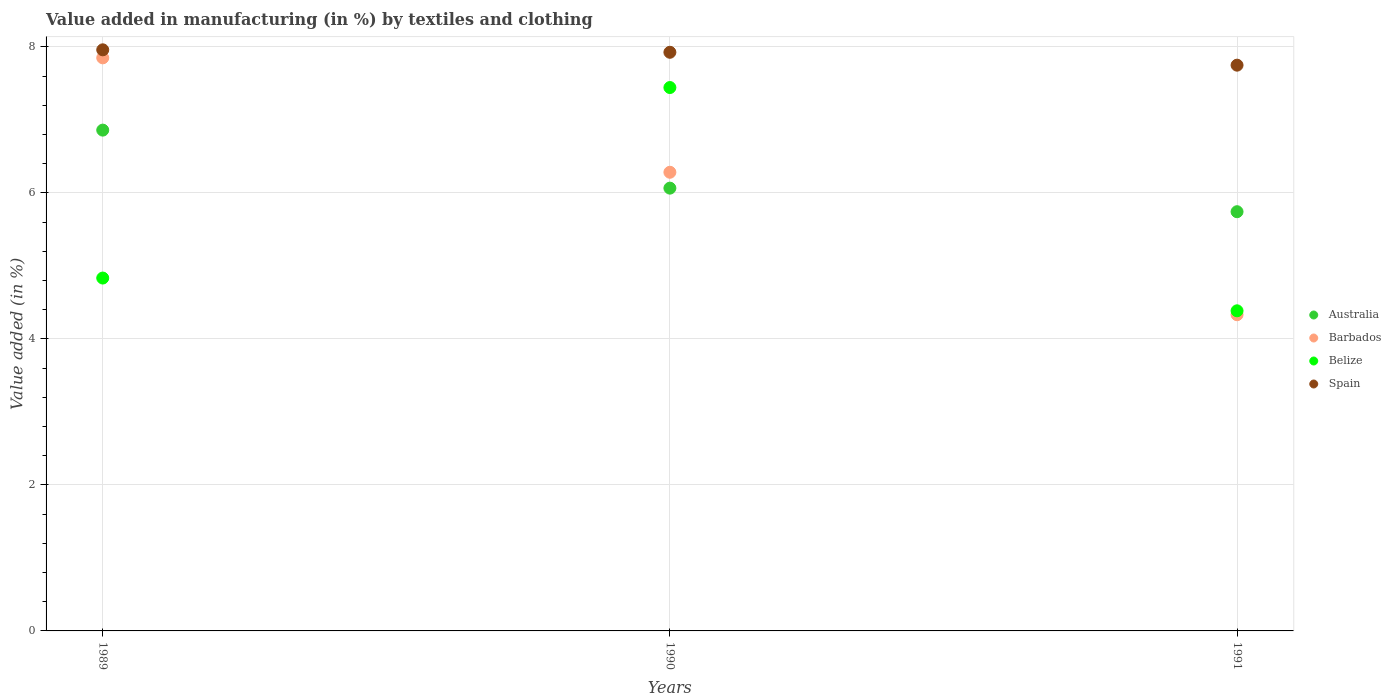Is the number of dotlines equal to the number of legend labels?
Your answer should be very brief. Yes. What is the percentage of value added in manufacturing by textiles and clothing in Belize in 1991?
Your answer should be compact. 4.39. Across all years, what is the maximum percentage of value added in manufacturing by textiles and clothing in Australia?
Offer a terse response. 6.86. Across all years, what is the minimum percentage of value added in manufacturing by textiles and clothing in Belize?
Ensure brevity in your answer.  4.39. In which year was the percentage of value added in manufacturing by textiles and clothing in Barbados maximum?
Keep it short and to the point. 1989. What is the total percentage of value added in manufacturing by textiles and clothing in Belize in the graph?
Provide a succinct answer. 16.66. What is the difference between the percentage of value added in manufacturing by textiles and clothing in Belize in 1990 and that in 1991?
Ensure brevity in your answer.  3.06. What is the difference between the percentage of value added in manufacturing by textiles and clothing in Australia in 1991 and the percentage of value added in manufacturing by textiles and clothing in Spain in 1990?
Your answer should be very brief. -2.18. What is the average percentage of value added in manufacturing by textiles and clothing in Belize per year?
Offer a terse response. 5.55. In the year 1990, what is the difference between the percentage of value added in manufacturing by textiles and clothing in Barbados and percentage of value added in manufacturing by textiles and clothing in Belize?
Give a very brief answer. -1.16. In how many years, is the percentage of value added in manufacturing by textiles and clothing in Australia greater than 3.6 %?
Make the answer very short. 3. What is the ratio of the percentage of value added in manufacturing by textiles and clothing in Barbados in 1989 to that in 1990?
Give a very brief answer. 1.25. Is the percentage of value added in manufacturing by textiles and clothing in Belize in 1989 less than that in 1991?
Keep it short and to the point. No. Is the difference between the percentage of value added in manufacturing by textiles and clothing in Barbados in 1990 and 1991 greater than the difference between the percentage of value added in manufacturing by textiles and clothing in Belize in 1990 and 1991?
Keep it short and to the point. No. What is the difference between the highest and the second highest percentage of value added in manufacturing by textiles and clothing in Australia?
Provide a succinct answer. 0.79. What is the difference between the highest and the lowest percentage of value added in manufacturing by textiles and clothing in Spain?
Provide a short and direct response. 0.21. Is the sum of the percentage of value added in manufacturing by textiles and clothing in Australia in 1990 and 1991 greater than the maximum percentage of value added in manufacturing by textiles and clothing in Barbados across all years?
Make the answer very short. Yes. Is the percentage of value added in manufacturing by textiles and clothing in Barbados strictly less than the percentage of value added in manufacturing by textiles and clothing in Spain over the years?
Provide a succinct answer. Yes. How many dotlines are there?
Give a very brief answer. 4. How many years are there in the graph?
Offer a terse response. 3. Are the values on the major ticks of Y-axis written in scientific E-notation?
Give a very brief answer. No. Where does the legend appear in the graph?
Ensure brevity in your answer.  Center right. How many legend labels are there?
Give a very brief answer. 4. How are the legend labels stacked?
Make the answer very short. Vertical. What is the title of the graph?
Offer a terse response. Value added in manufacturing (in %) by textiles and clothing. Does "Timor-Leste" appear as one of the legend labels in the graph?
Offer a terse response. No. What is the label or title of the X-axis?
Ensure brevity in your answer.  Years. What is the label or title of the Y-axis?
Keep it short and to the point. Value added (in %). What is the Value added (in %) in Australia in 1989?
Ensure brevity in your answer.  6.86. What is the Value added (in %) in Barbados in 1989?
Your response must be concise. 7.85. What is the Value added (in %) in Belize in 1989?
Provide a short and direct response. 4.83. What is the Value added (in %) in Spain in 1989?
Give a very brief answer. 7.96. What is the Value added (in %) of Australia in 1990?
Your response must be concise. 6.07. What is the Value added (in %) of Barbados in 1990?
Keep it short and to the point. 6.28. What is the Value added (in %) in Belize in 1990?
Give a very brief answer. 7.44. What is the Value added (in %) of Spain in 1990?
Provide a short and direct response. 7.93. What is the Value added (in %) in Australia in 1991?
Provide a short and direct response. 5.74. What is the Value added (in %) in Barbados in 1991?
Give a very brief answer. 4.33. What is the Value added (in %) of Belize in 1991?
Your answer should be compact. 4.39. What is the Value added (in %) in Spain in 1991?
Offer a very short reply. 7.75. Across all years, what is the maximum Value added (in %) of Australia?
Your answer should be compact. 6.86. Across all years, what is the maximum Value added (in %) of Barbados?
Your answer should be very brief. 7.85. Across all years, what is the maximum Value added (in %) of Belize?
Keep it short and to the point. 7.44. Across all years, what is the maximum Value added (in %) of Spain?
Keep it short and to the point. 7.96. Across all years, what is the minimum Value added (in %) of Australia?
Provide a short and direct response. 5.74. Across all years, what is the minimum Value added (in %) in Barbados?
Give a very brief answer. 4.33. Across all years, what is the minimum Value added (in %) of Belize?
Your answer should be compact. 4.39. Across all years, what is the minimum Value added (in %) of Spain?
Make the answer very short. 7.75. What is the total Value added (in %) of Australia in the graph?
Your answer should be very brief. 18.67. What is the total Value added (in %) in Barbados in the graph?
Make the answer very short. 18.46. What is the total Value added (in %) of Belize in the graph?
Offer a terse response. 16.66. What is the total Value added (in %) in Spain in the graph?
Give a very brief answer. 23.64. What is the difference between the Value added (in %) in Australia in 1989 and that in 1990?
Keep it short and to the point. 0.79. What is the difference between the Value added (in %) in Barbados in 1989 and that in 1990?
Give a very brief answer. 1.57. What is the difference between the Value added (in %) of Belize in 1989 and that in 1990?
Give a very brief answer. -2.61. What is the difference between the Value added (in %) of Spain in 1989 and that in 1990?
Offer a terse response. 0.03. What is the difference between the Value added (in %) of Australia in 1989 and that in 1991?
Make the answer very short. 1.12. What is the difference between the Value added (in %) of Barbados in 1989 and that in 1991?
Offer a very short reply. 3.52. What is the difference between the Value added (in %) in Belize in 1989 and that in 1991?
Provide a succinct answer. 0.45. What is the difference between the Value added (in %) of Spain in 1989 and that in 1991?
Offer a very short reply. 0.21. What is the difference between the Value added (in %) in Australia in 1990 and that in 1991?
Provide a succinct answer. 0.32. What is the difference between the Value added (in %) in Barbados in 1990 and that in 1991?
Offer a terse response. 1.95. What is the difference between the Value added (in %) of Belize in 1990 and that in 1991?
Ensure brevity in your answer.  3.06. What is the difference between the Value added (in %) of Spain in 1990 and that in 1991?
Your answer should be compact. 0.18. What is the difference between the Value added (in %) of Australia in 1989 and the Value added (in %) of Barbados in 1990?
Your response must be concise. 0.58. What is the difference between the Value added (in %) of Australia in 1989 and the Value added (in %) of Belize in 1990?
Offer a terse response. -0.58. What is the difference between the Value added (in %) in Australia in 1989 and the Value added (in %) in Spain in 1990?
Keep it short and to the point. -1.07. What is the difference between the Value added (in %) in Barbados in 1989 and the Value added (in %) in Belize in 1990?
Provide a short and direct response. 0.41. What is the difference between the Value added (in %) in Barbados in 1989 and the Value added (in %) in Spain in 1990?
Your response must be concise. -0.08. What is the difference between the Value added (in %) in Belize in 1989 and the Value added (in %) in Spain in 1990?
Provide a short and direct response. -3.09. What is the difference between the Value added (in %) in Australia in 1989 and the Value added (in %) in Barbados in 1991?
Offer a very short reply. 2.53. What is the difference between the Value added (in %) in Australia in 1989 and the Value added (in %) in Belize in 1991?
Keep it short and to the point. 2.48. What is the difference between the Value added (in %) in Australia in 1989 and the Value added (in %) in Spain in 1991?
Provide a short and direct response. -0.89. What is the difference between the Value added (in %) in Barbados in 1989 and the Value added (in %) in Belize in 1991?
Your response must be concise. 3.47. What is the difference between the Value added (in %) in Barbados in 1989 and the Value added (in %) in Spain in 1991?
Make the answer very short. 0.1. What is the difference between the Value added (in %) in Belize in 1989 and the Value added (in %) in Spain in 1991?
Offer a very short reply. -2.92. What is the difference between the Value added (in %) in Australia in 1990 and the Value added (in %) in Barbados in 1991?
Offer a very short reply. 1.73. What is the difference between the Value added (in %) in Australia in 1990 and the Value added (in %) in Belize in 1991?
Provide a succinct answer. 1.68. What is the difference between the Value added (in %) of Australia in 1990 and the Value added (in %) of Spain in 1991?
Ensure brevity in your answer.  -1.68. What is the difference between the Value added (in %) of Barbados in 1990 and the Value added (in %) of Belize in 1991?
Make the answer very short. 1.9. What is the difference between the Value added (in %) of Barbados in 1990 and the Value added (in %) of Spain in 1991?
Keep it short and to the point. -1.47. What is the difference between the Value added (in %) of Belize in 1990 and the Value added (in %) of Spain in 1991?
Provide a short and direct response. -0.31. What is the average Value added (in %) of Australia per year?
Offer a very short reply. 6.22. What is the average Value added (in %) in Barbados per year?
Keep it short and to the point. 6.15. What is the average Value added (in %) in Belize per year?
Offer a terse response. 5.55. What is the average Value added (in %) in Spain per year?
Your answer should be very brief. 7.88. In the year 1989, what is the difference between the Value added (in %) in Australia and Value added (in %) in Barbados?
Offer a terse response. -0.99. In the year 1989, what is the difference between the Value added (in %) of Australia and Value added (in %) of Belize?
Your answer should be very brief. 2.03. In the year 1989, what is the difference between the Value added (in %) in Barbados and Value added (in %) in Belize?
Provide a short and direct response. 3.02. In the year 1989, what is the difference between the Value added (in %) of Barbados and Value added (in %) of Spain?
Provide a succinct answer. -0.11. In the year 1989, what is the difference between the Value added (in %) in Belize and Value added (in %) in Spain?
Make the answer very short. -3.13. In the year 1990, what is the difference between the Value added (in %) of Australia and Value added (in %) of Barbados?
Your answer should be compact. -0.22. In the year 1990, what is the difference between the Value added (in %) of Australia and Value added (in %) of Belize?
Offer a terse response. -1.38. In the year 1990, what is the difference between the Value added (in %) in Australia and Value added (in %) in Spain?
Ensure brevity in your answer.  -1.86. In the year 1990, what is the difference between the Value added (in %) in Barbados and Value added (in %) in Belize?
Make the answer very short. -1.16. In the year 1990, what is the difference between the Value added (in %) in Barbados and Value added (in %) in Spain?
Make the answer very short. -1.64. In the year 1990, what is the difference between the Value added (in %) in Belize and Value added (in %) in Spain?
Offer a terse response. -0.48. In the year 1991, what is the difference between the Value added (in %) of Australia and Value added (in %) of Barbados?
Keep it short and to the point. 1.41. In the year 1991, what is the difference between the Value added (in %) of Australia and Value added (in %) of Belize?
Give a very brief answer. 1.36. In the year 1991, what is the difference between the Value added (in %) of Australia and Value added (in %) of Spain?
Your answer should be compact. -2.01. In the year 1991, what is the difference between the Value added (in %) in Barbados and Value added (in %) in Belize?
Make the answer very short. -0.05. In the year 1991, what is the difference between the Value added (in %) in Barbados and Value added (in %) in Spain?
Make the answer very short. -3.42. In the year 1991, what is the difference between the Value added (in %) in Belize and Value added (in %) in Spain?
Provide a succinct answer. -3.37. What is the ratio of the Value added (in %) in Australia in 1989 to that in 1990?
Offer a terse response. 1.13. What is the ratio of the Value added (in %) in Barbados in 1989 to that in 1990?
Provide a succinct answer. 1.25. What is the ratio of the Value added (in %) in Belize in 1989 to that in 1990?
Provide a succinct answer. 0.65. What is the ratio of the Value added (in %) of Spain in 1989 to that in 1990?
Offer a very short reply. 1. What is the ratio of the Value added (in %) in Australia in 1989 to that in 1991?
Your answer should be compact. 1.19. What is the ratio of the Value added (in %) of Barbados in 1989 to that in 1991?
Make the answer very short. 1.81. What is the ratio of the Value added (in %) in Belize in 1989 to that in 1991?
Ensure brevity in your answer.  1.1. What is the ratio of the Value added (in %) in Spain in 1989 to that in 1991?
Offer a terse response. 1.03. What is the ratio of the Value added (in %) of Australia in 1990 to that in 1991?
Provide a short and direct response. 1.06. What is the ratio of the Value added (in %) in Barbados in 1990 to that in 1991?
Your answer should be very brief. 1.45. What is the ratio of the Value added (in %) in Belize in 1990 to that in 1991?
Provide a short and direct response. 1.7. What is the ratio of the Value added (in %) in Spain in 1990 to that in 1991?
Your answer should be compact. 1.02. What is the difference between the highest and the second highest Value added (in %) in Australia?
Keep it short and to the point. 0.79. What is the difference between the highest and the second highest Value added (in %) in Barbados?
Your response must be concise. 1.57. What is the difference between the highest and the second highest Value added (in %) of Belize?
Make the answer very short. 2.61. What is the difference between the highest and the second highest Value added (in %) of Spain?
Your answer should be compact. 0.03. What is the difference between the highest and the lowest Value added (in %) in Australia?
Your response must be concise. 1.12. What is the difference between the highest and the lowest Value added (in %) of Barbados?
Your response must be concise. 3.52. What is the difference between the highest and the lowest Value added (in %) of Belize?
Make the answer very short. 3.06. What is the difference between the highest and the lowest Value added (in %) of Spain?
Provide a succinct answer. 0.21. 